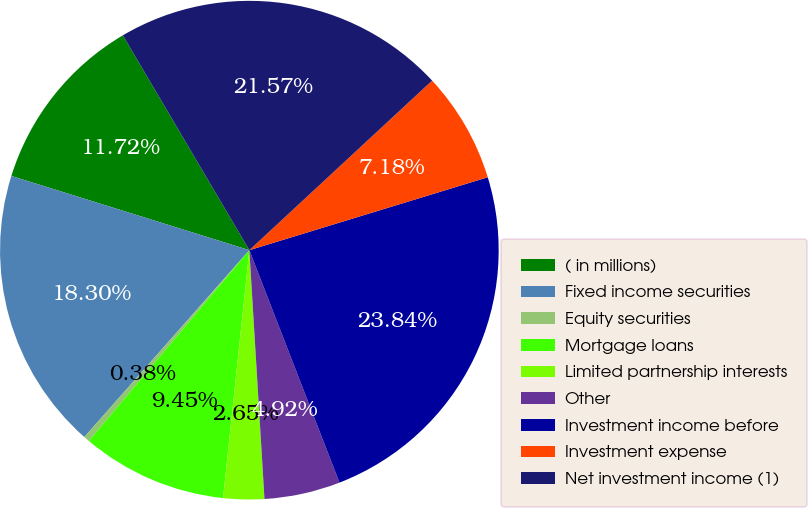Convert chart to OTSL. <chart><loc_0><loc_0><loc_500><loc_500><pie_chart><fcel>( in millions)<fcel>Fixed income securities<fcel>Equity securities<fcel>Mortgage loans<fcel>Limited partnership interests<fcel>Other<fcel>Investment income before<fcel>Investment expense<fcel>Net investment income (1)<nl><fcel>11.72%<fcel>18.3%<fcel>0.38%<fcel>9.45%<fcel>2.65%<fcel>4.92%<fcel>23.84%<fcel>7.18%<fcel>21.57%<nl></chart> 